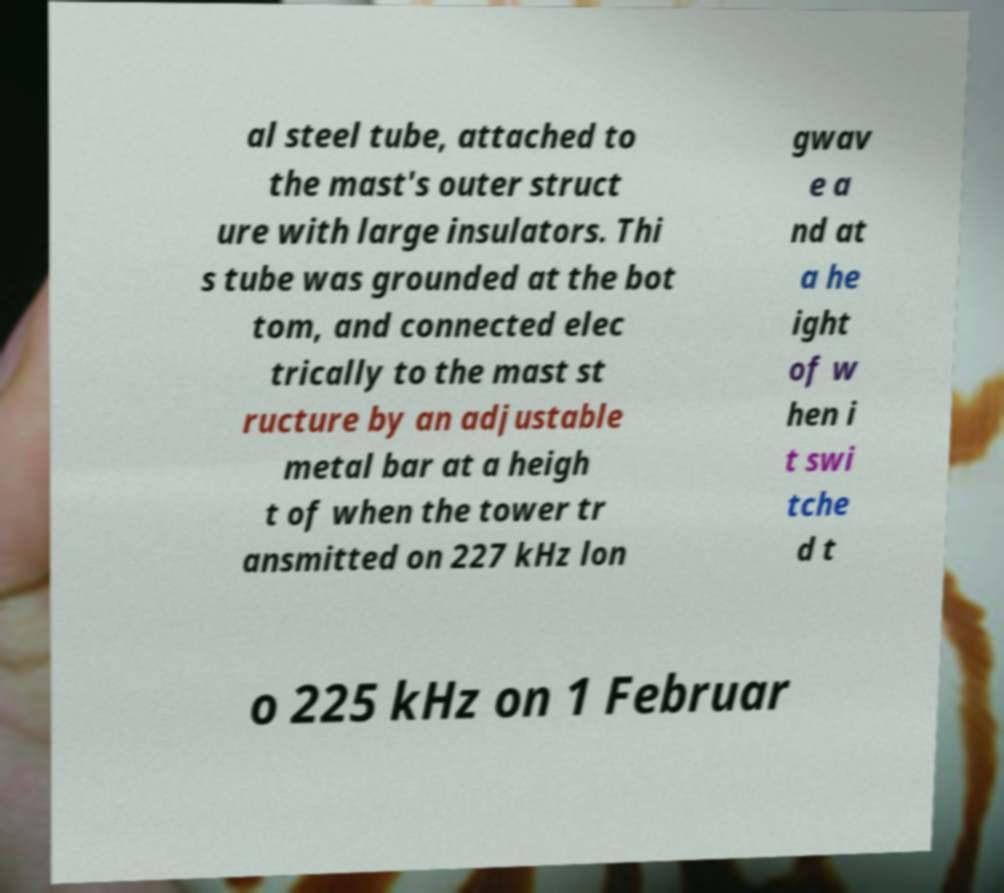Can you accurately transcribe the text from the provided image for me? al steel tube, attached to the mast's outer struct ure with large insulators. Thi s tube was grounded at the bot tom, and connected elec trically to the mast st ructure by an adjustable metal bar at a heigh t of when the tower tr ansmitted on 227 kHz lon gwav e a nd at a he ight of w hen i t swi tche d t o 225 kHz on 1 Februar 